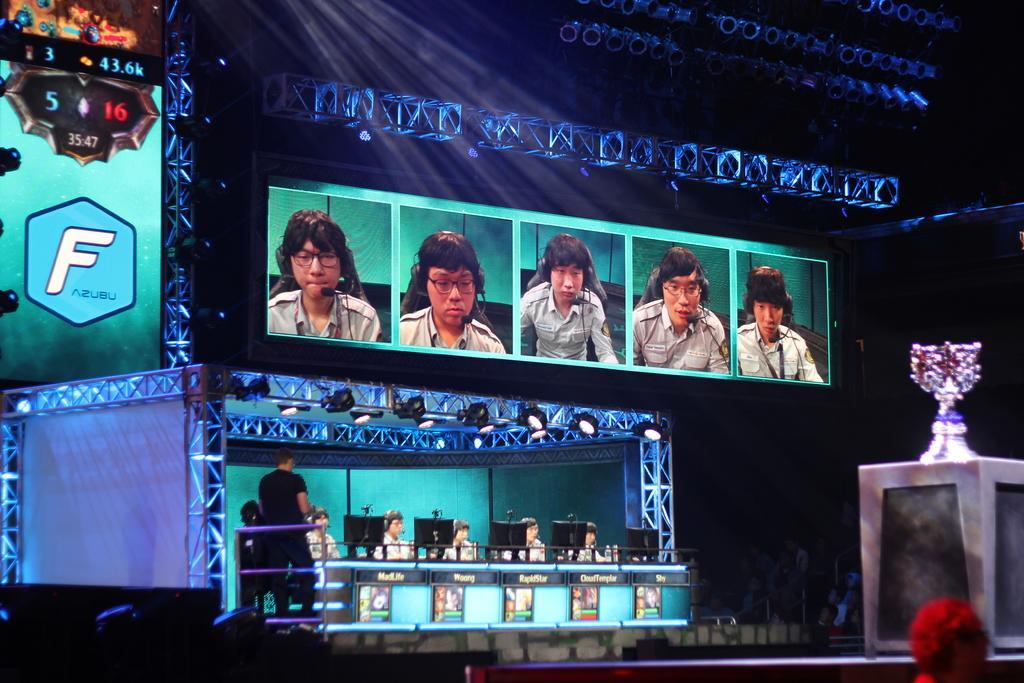Could you give a brief overview of what you see in this image? In this image we can see people sitting on chairs wearing headphones. In front of them there are monitors. There is person standing wearing a black color T-shirt. At the top of the image there is a screen on which there are images of persons. There are rods, posters, lights. To the right side of the image there is a trophy. 